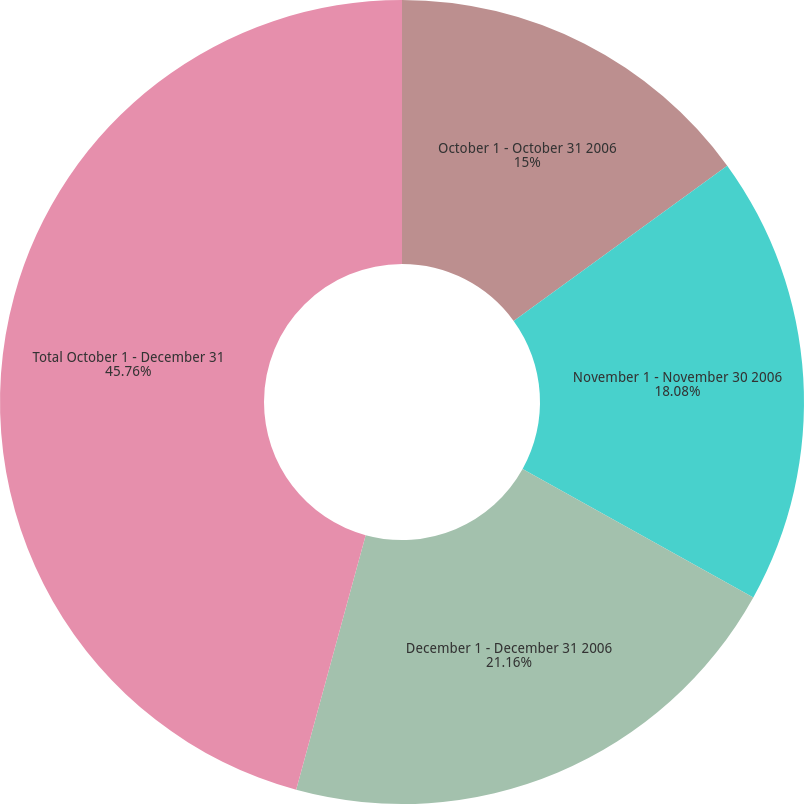Convert chart. <chart><loc_0><loc_0><loc_500><loc_500><pie_chart><fcel>October 1 - October 31 2006<fcel>November 1 - November 30 2006<fcel>December 1 - December 31 2006<fcel>Total October 1 - December 31<nl><fcel>15.0%<fcel>18.08%<fcel>21.16%<fcel>45.76%<nl></chart> 